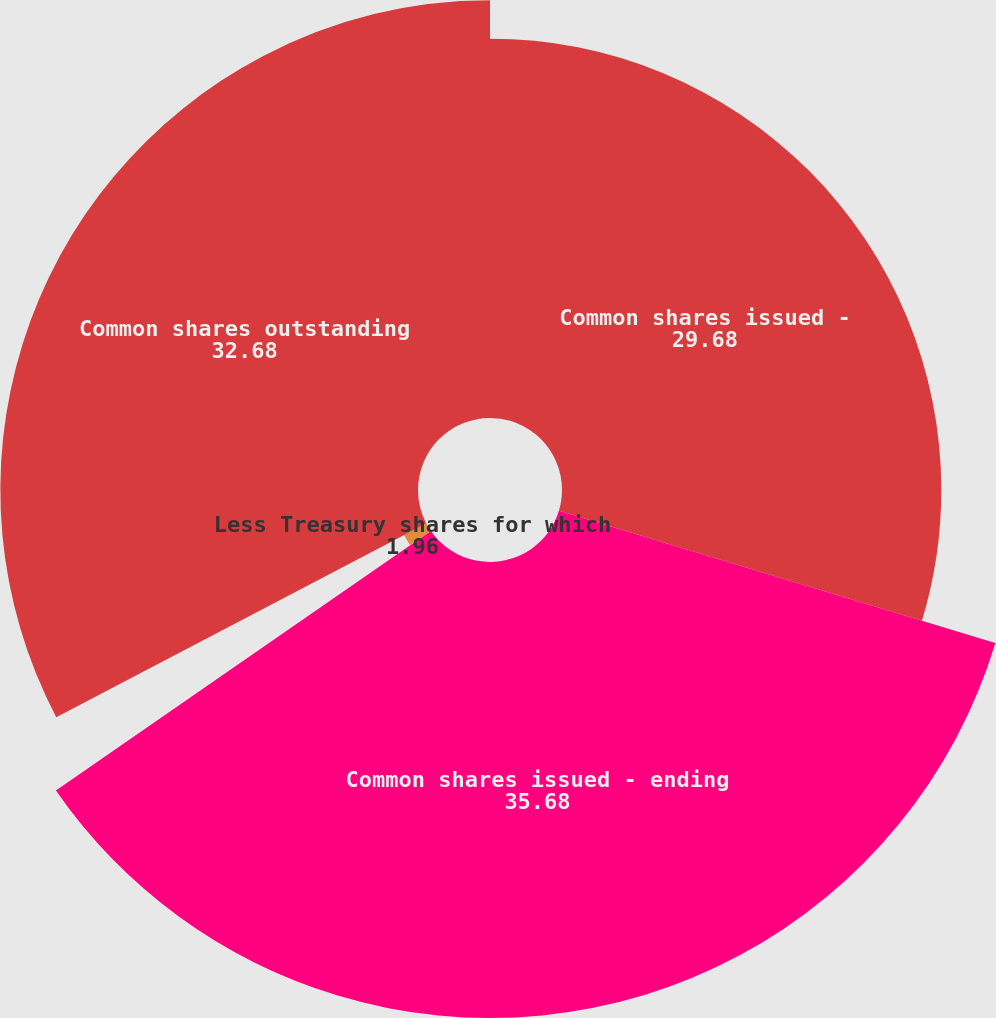Convert chart to OTSL. <chart><loc_0><loc_0><loc_500><loc_500><pie_chart><fcel>Common shares issued -<fcel>Common shares issued - ending<fcel>Less Treasury shares for which<fcel>Common shares outstanding<nl><fcel>29.68%<fcel>35.68%<fcel>1.96%<fcel>32.68%<nl></chart> 